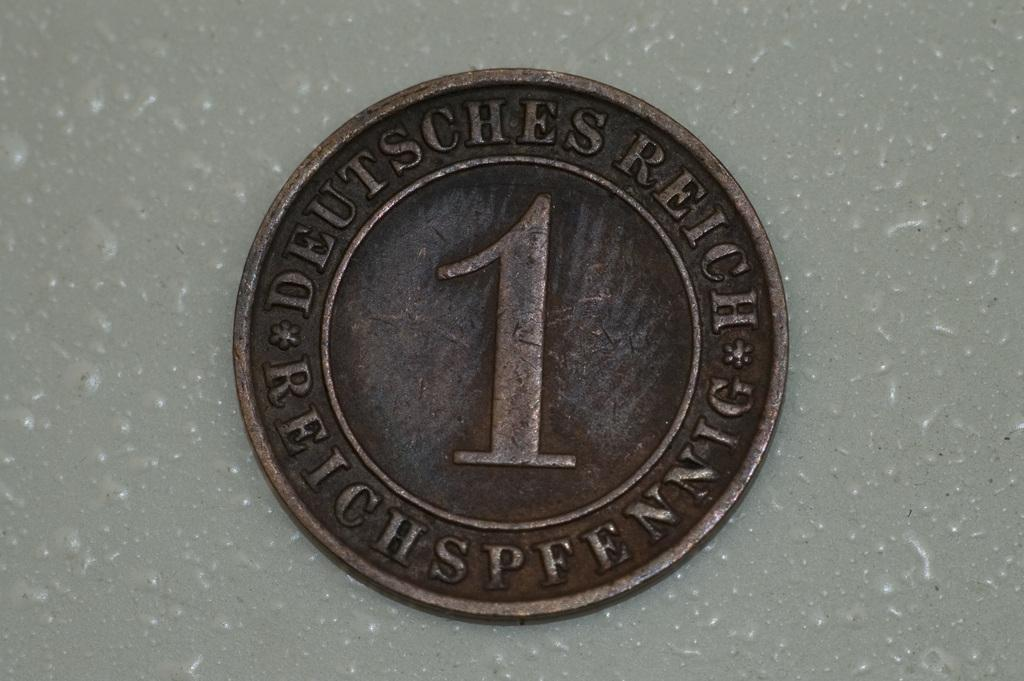<image>
Provide a brief description of the given image. A brown coin with writing that says DEUTSCHES REICH*REICHSPFENNIG*. 